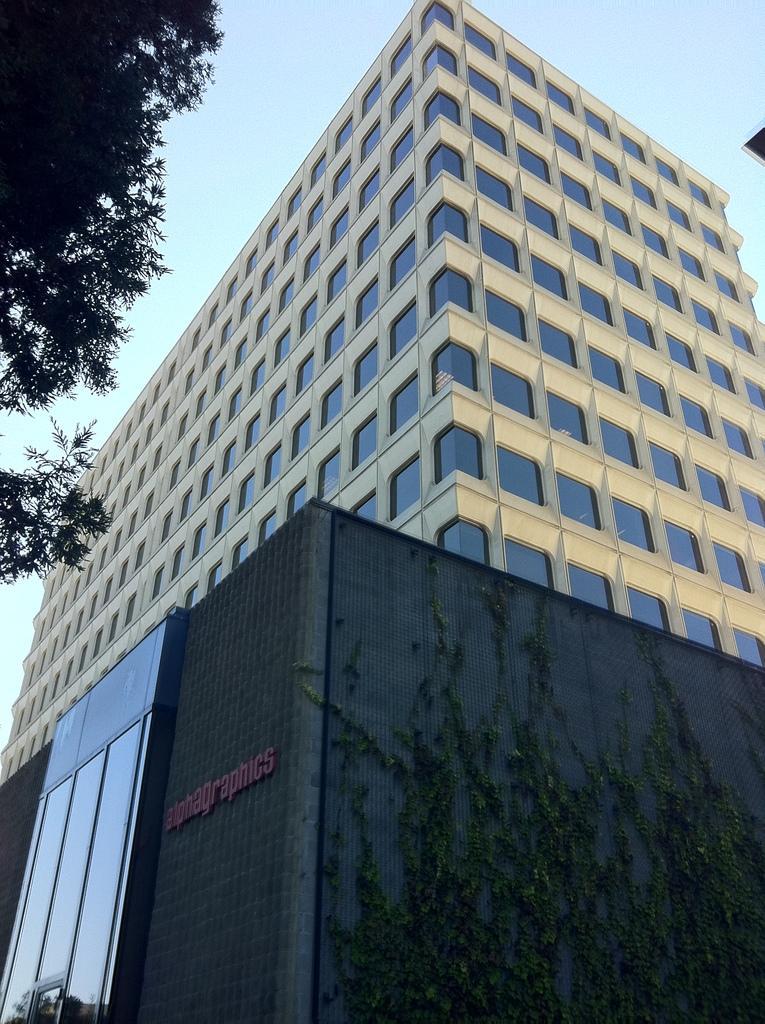Please provide a concise description of this image. In this image there is a building, in the background there is the sky, on the top left there is a tree. 